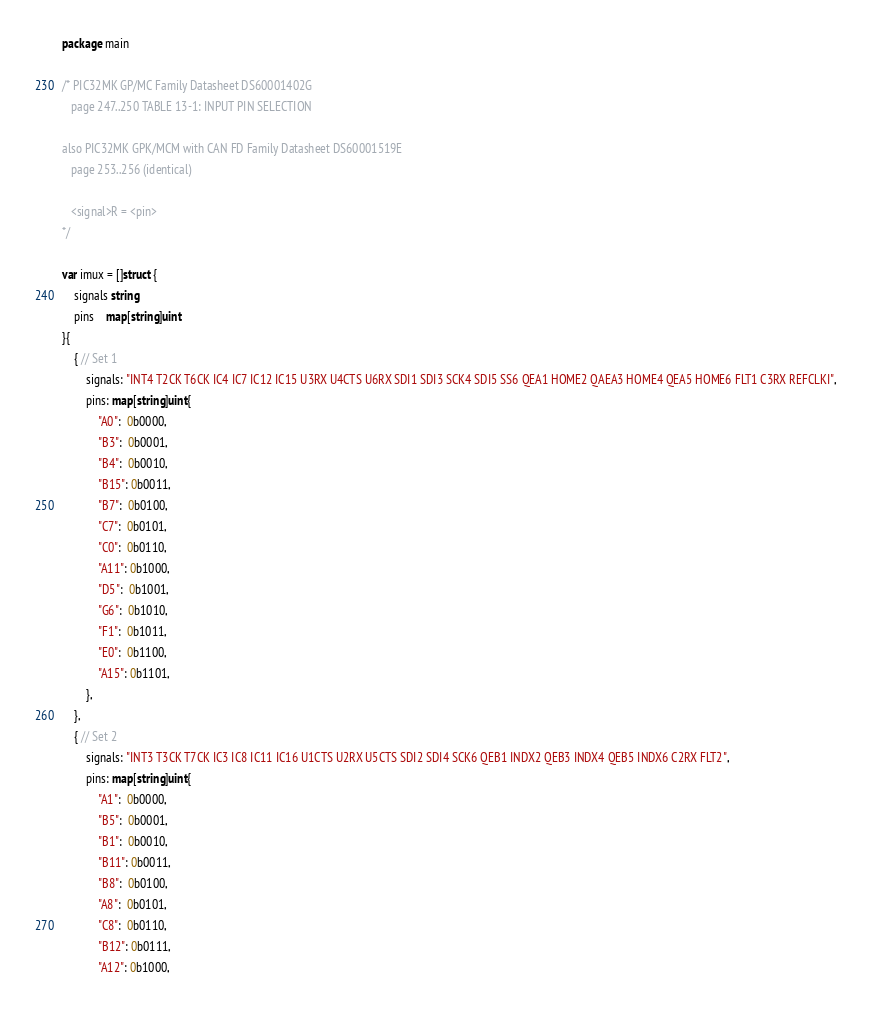Convert code to text. <code><loc_0><loc_0><loc_500><loc_500><_Go_>package main

/* PIC32MK GP/MC Family Datasheet DS60001402G
   page 247..250 TABLE 13-1: INPUT PIN SELECTION

also PIC32MK GPK/MCM with CAN FD Family Datasheet DS60001519E
   page 253..256 (identical)

   <signal>R = <pin>
*/

var imux = []struct {
	signals string
	pins    map[string]uint
}{
	{ // Set 1
		signals: "INT4 T2CK T6CK IC4 IC7 IC12 IC15 U3RX U4CTS U6RX SDI1 SDI3 SCK4 SDI5 SS6 QEA1 HOME2 QAEA3 HOME4 QEA5 HOME6 FLT1 C3RX REFCLKI",
		pins: map[string]uint{
			"A0":  0b0000,
			"B3":  0b0001,
			"B4":  0b0010,
			"B15": 0b0011,
			"B7":  0b0100,
			"C7":  0b0101,
			"C0":  0b0110,
			"A11": 0b1000,
			"D5":  0b1001,
			"G6":  0b1010,
			"F1":  0b1011,
			"E0":  0b1100,
			"A15": 0b1101,
		},
	},
	{ // Set 2
		signals: "INT3 T3CK T7CK IC3 IC8 IC11 IC16 U1CTS U2RX U5CTS SDI2 SDI4 SCK6 QEB1 INDX2 QEB3 INDX4 QEB5 INDX6 C2RX FLT2",
		pins: map[string]uint{
			"A1":  0b0000,
			"B5":  0b0001,
			"B1":  0b0010,
			"B11": 0b0011,
			"B8":  0b0100,
			"A8":  0b0101,
			"C8":  0b0110,
			"B12": 0b0111,
			"A12": 0b1000,</code> 